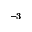<formula> <loc_0><loc_0><loc_500><loc_500>^ { - 3 }</formula> 